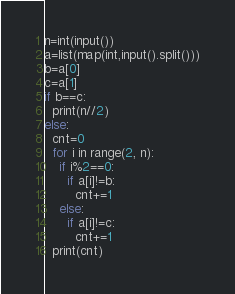<code> <loc_0><loc_0><loc_500><loc_500><_Python_>n=int(input())
a=list(map(int,input().split()))
b=a[0]
c=a[1]
if b==c:
  print(n//2)
else:
  cnt=0
  for i in range(2, n):
    if i%2==0:
      if a[i]!=b:
        cnt+=1
    else:
      if a[i]!=c:
        cnt+=1
  print(cnt)</code> 